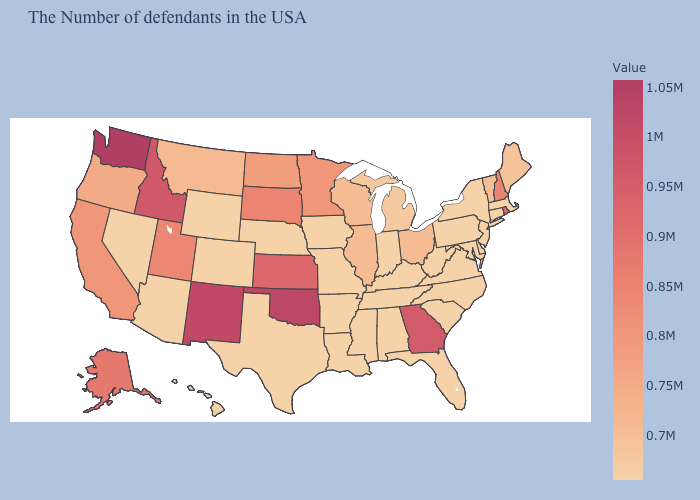Does Connecticut have the lowest value in the USA?
Concise answer only. Yes. Is the legend a continuous bar?
Concise answer only. Yes. Which states hav the highest value in the West?
Answer briefly. Washington. Does Vermont have the lowest value in the USA?
Be succinct. No. Among the states that border Illinois , does Wisconsin have the highest value?
Give a very brief answer. Yes. 